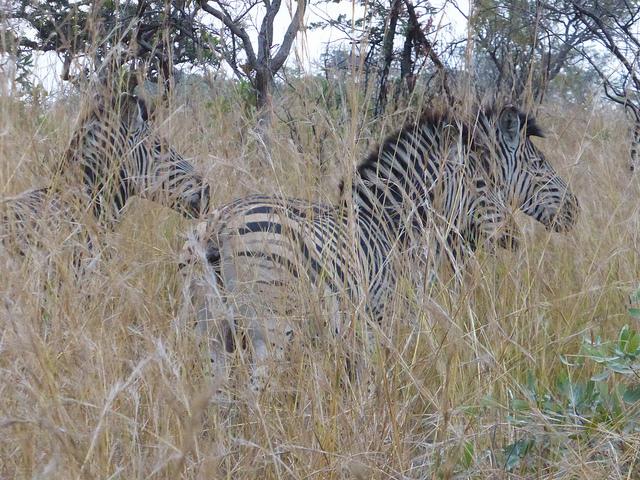How many legs do the striped animals have all together?
Quick response, please. 12. How many animals are there?
Write a very short answer. 3. What kind of animals are these?
Write a very short answer. Zebra. What animal is seen in the scene?
Short answer required. Zebra. What is the baby zebra doing?
Give a very brief answer. Standing. What is this animal?
Quick response, please. Zebra. What animal is this?
Write a very short answer. Zebra. What is that animal?
Answer briefly. Zebra. How many zebras is in the picture?
Keep it brief. 3. What scene is this animal seen?
Short answer required. Grass. Where are the zebras?
Short answer required. In grass. What kind of animal is in the picture?
Be succinct. Zebra. Why are the animals necks so long?
Write a very short answer. To eat. The animal is feeding?
Quick response, please. No. 